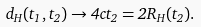<formula> <loc_0><loc_0><loc_500><loc_500>d _ { H } ( t _ { 1 } , t _ { 2 } ) \rightarrow 4 c t _ { 2 } = 2 R _ { H } ( t _ { 2 } ) .</formula> 